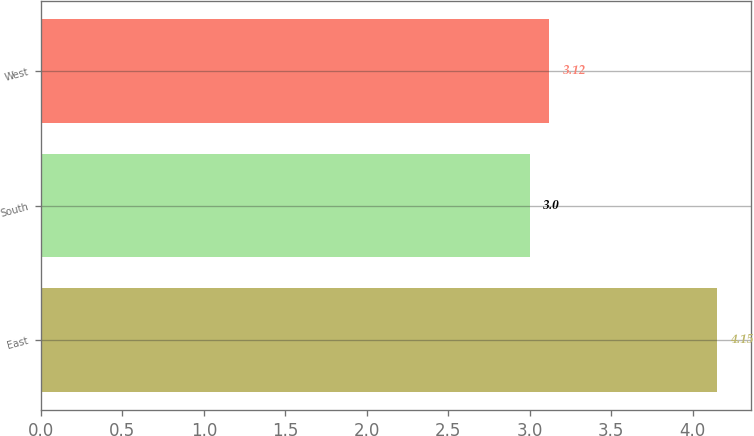<chart> <loc_0><loc_0><loc_500><loc_500><bar_chart><fcel>East<fcel>South<fcel>West<nl><fcel>4.15<fcel>3<fcel>3.12<nl></chart> 